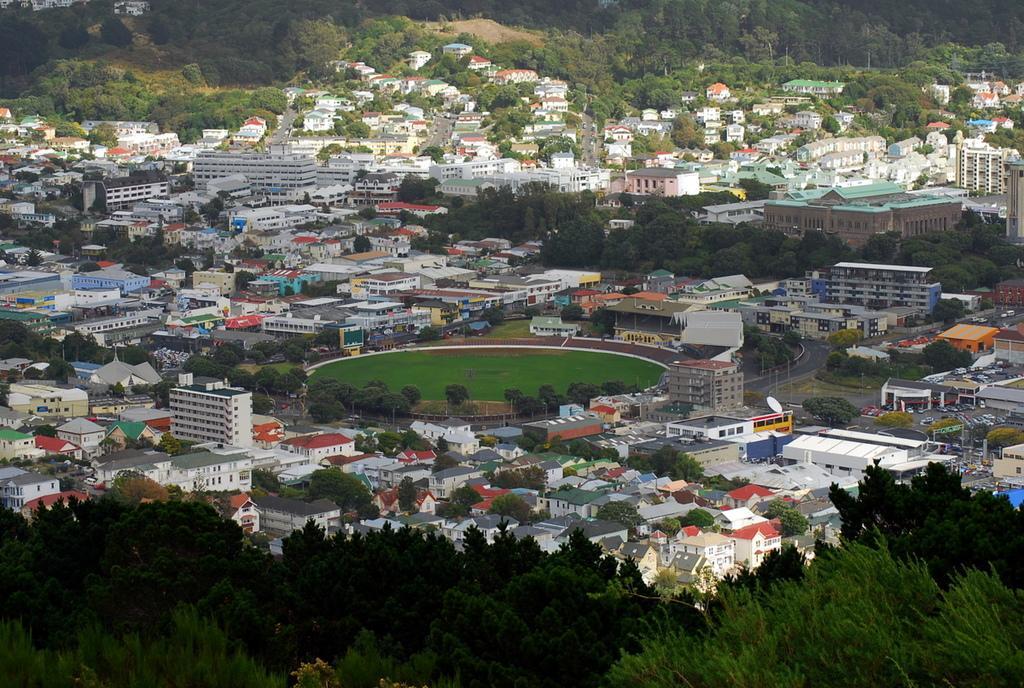Could you give a brief overview of what you see in this image? At the bottom of the image there are trees. And in the image there are buildings, trees, roads and stores. In the middle of the buildings there is a ground. At the top of the image there are trees. 